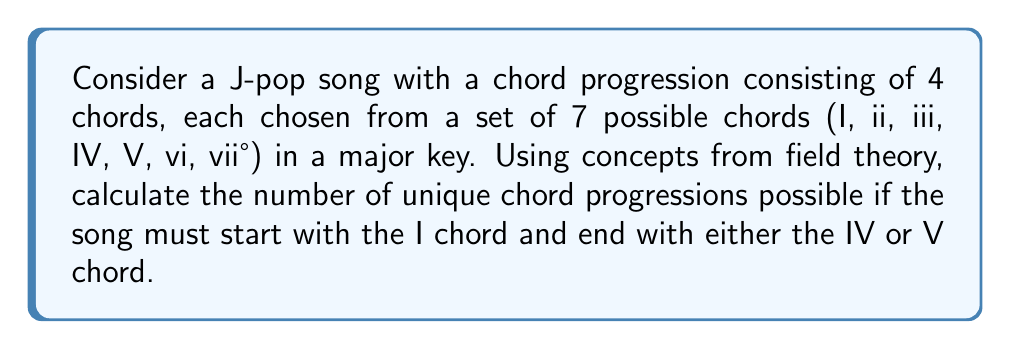Could you help me with this problem? Let's approach this step-by-step using field theory concepts:

1) First, we can think of the chord progression as a vector in a 4-dimensional vector space over a finite field $\mathbb{F}_7$ (representing the 7 possible chords).

2) The constraints given are:
   - The first chord must be I (represented by 1 in $\mathbb{F}_7$)
   - The last chord must be either IV or V (represented by 4 or 5 in $\mathbb{F}_7$)
   - The middle two chords can be any of the 7 chords

3) We can represent this as a system of linear equations:
   $$\begin{cases}
   x_1 = 1 \\
   x_4 \in \{4, 5\} \\
   x_2, x_3 \in \mathbb{F}_7
   \end{cases}$$

4) The number of solutions to this system will give us the number of possible chord progressions.

5) For the middle two chords, we have 7 choices each, so there are $7 * 7 = 49$ possibilities.

6) For the last chord, we have 2 choices.

7) By the multiplication principle, the total number of possibilities is:
   $$1 * 7 * 7 * 2 = 98$$

Therefore, there are 98 possible chord progressions satisfying the given conditions.
Answer: 98 